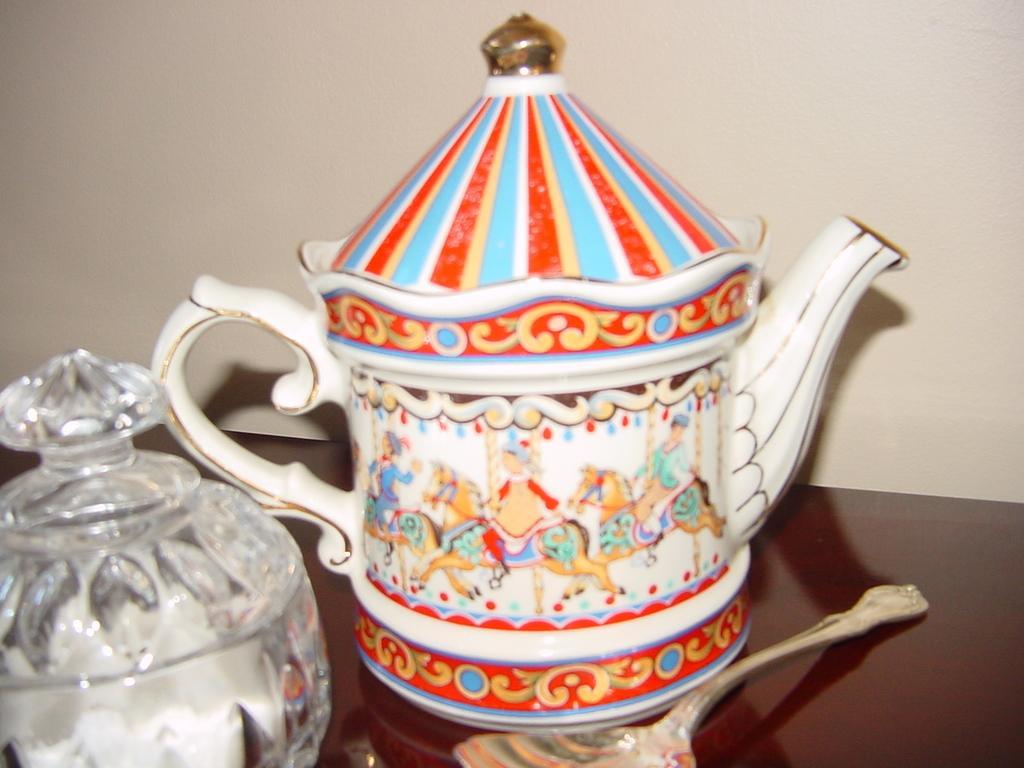Can you describe this image briefly? In this image I can see the brown colored surface and on it I can see a spoon, a tea container which is white, cream and red in color and a glass bowl. In the background I can see the cream colored surface. 